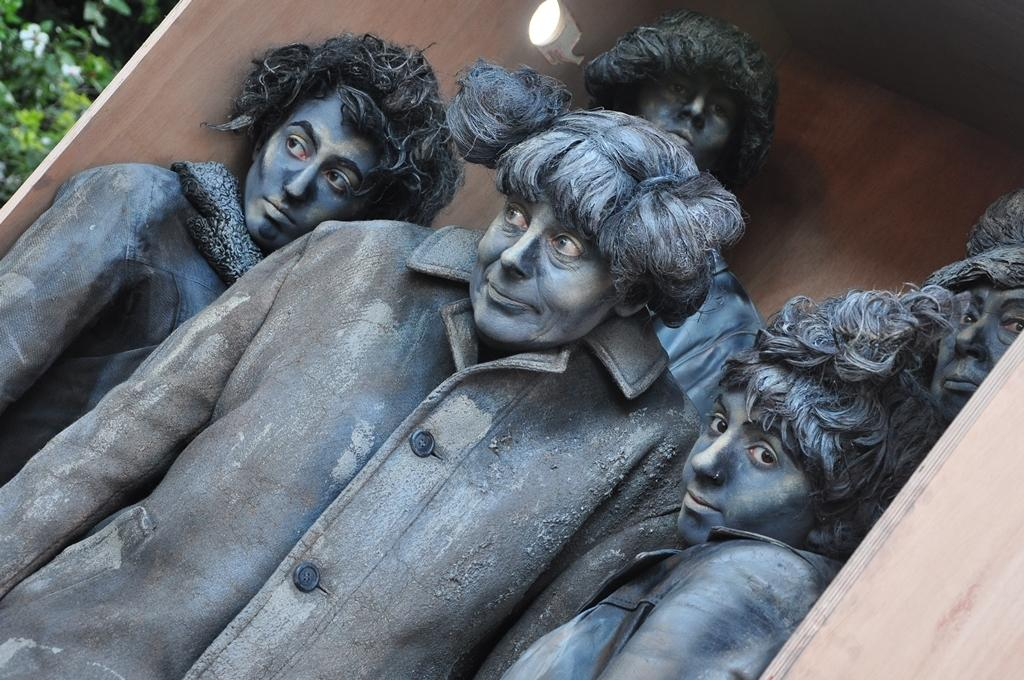What can be seen in the image? There is a group of people in the image. What are the people wearing? The people are wearing clothes. Can you describe the lighting in the image? There is a light at the top of the image. What type of flesh can be seen on the people in the image? There is no mention of flesh in the image, and it is not appropriate to focus on the physical appearance of the people in this context. 